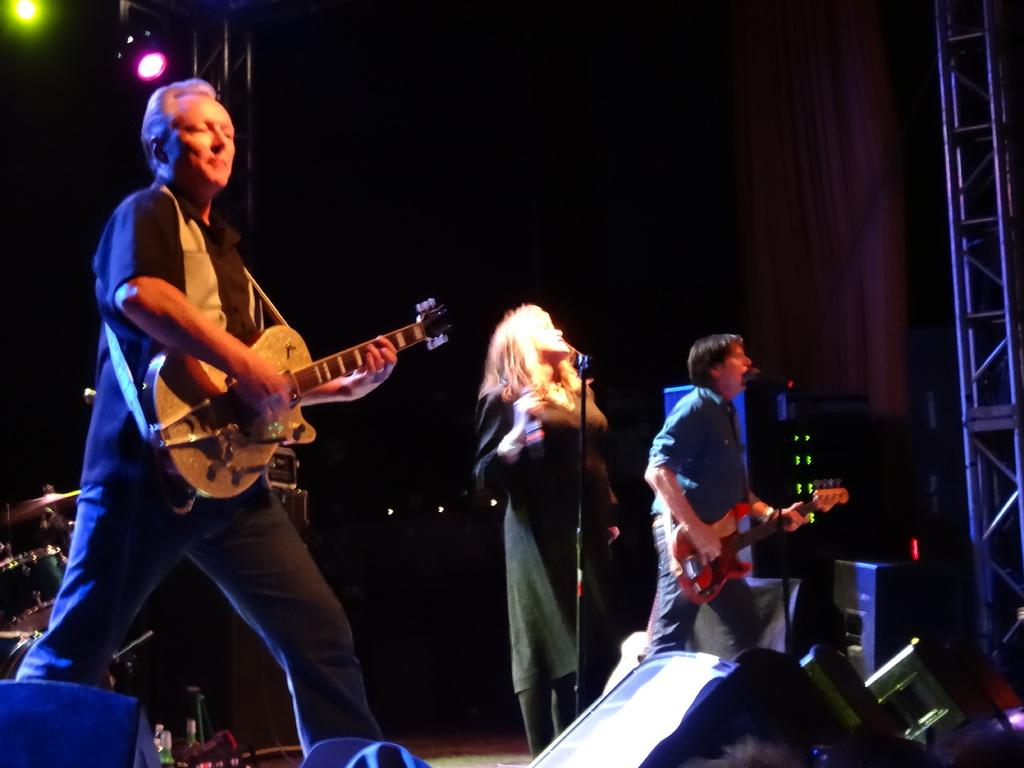How many people are in the image? There are two men and a woman in the image, making a total of three individuals. What are the individuals doing in the image? The individuals are standing and holding guitars. What else can be seen in the image besides the people? There are musical instruments and lights in the background of the image. What type of tooth is visible in the image? There is no tooth visible in the image. Who is the mother of the individuals in the image? The provided facts do not mention any mothers or family relationships among the individuals in the image. 